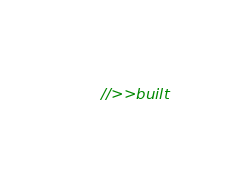Convert code to text. <code><loc_0><loc_0><loc_500><loc_500><_JavaScript_>//>>built</code> 